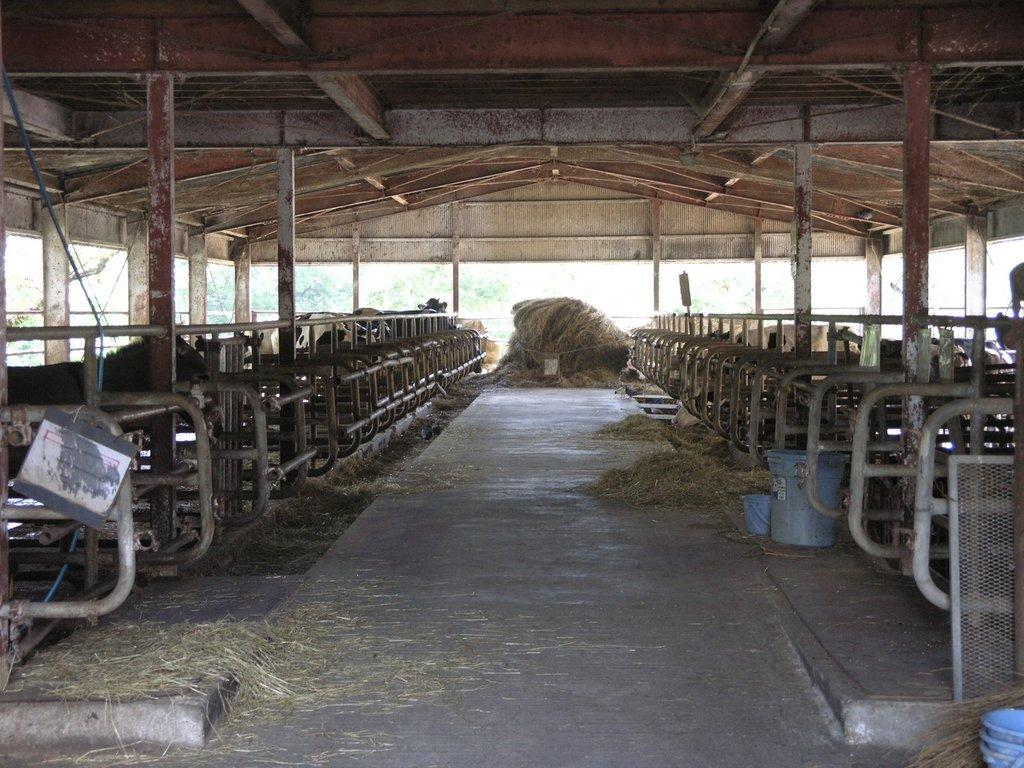What structure can be seen in the image? There is a shed in the image. What is located behind the shed? There are trees behind the shed. What type of vegetation is present inside the shed? There is grass inside the shed. What type of enclosure is present in the shed? There are fencings in the shed. What type of living beings can be seen in the shed? There are animals in the shed. What type of containers are present in the shed? There are tubs in the shed. What type of silverware is visible in the image? There is no silverware present in the image. Can you see any branches inside the shed? There is no mention of branches in the image; it only mentions trees behind the shed. Are there any skateboards visible in the image? There is no mention of skateboards in the image. 